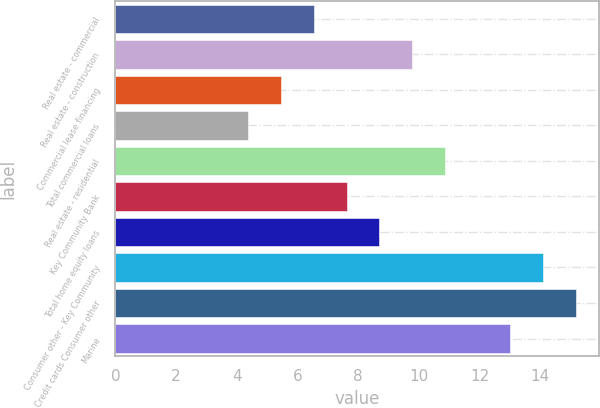Convert chart. <chart><loc_0><loc_0><loc_500><loc_500><bar_chart><fcel>Real estate - commercial<fcel>Real estate - construction<fcel>Commercial lease financing<fcel>Total commercial loans<fcel>Real estate - residential<fcel>Key Community Bank<fcel>Total home equity loans<fcel>Consumer other - Key Community<fcel>Credit cards Consumer other<fcel>Marine<nl><fcel>6.54<fcel>9.78<fcel>5.46<fcel>4.38<fcel>10.86<fcel>7.62<fcel>8.7<fcel>14.1<fcel>15.18<fcel>13.02<nl></chart> 